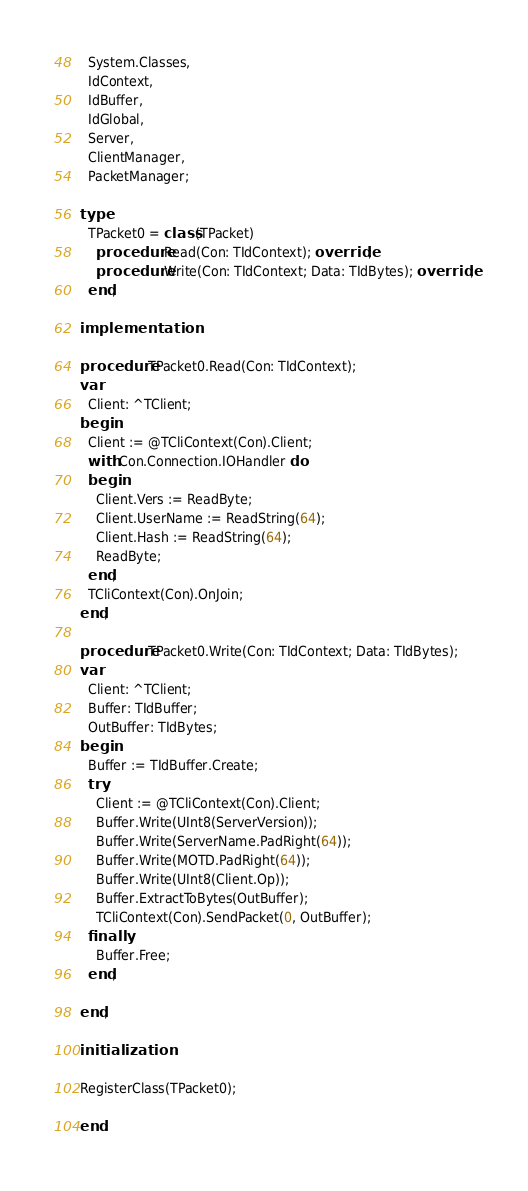Convert code to text. <code><loc_0><loc_0><loc_500><loc_500><_Pascal_>  System.Classes,
  IdContext,
  IdBuffer,
  IdGlobal,
  Server,
  ClientManager,
  PacketManager;

type
  TPacket0 = class(TPacket)
    procedure Read(Con: TIdContext); override;
    procedure Write(Con: TIdContext; Data: TIdBytes); override;
  end;

implementation

procedure TPacket0.Read(Con: TIdContext);
var
  Client: ^TClient;
begin
  Client := @TCliContext(Con).Client;
  with Con.Connection.IOHandler do
  begin
    Client.Vers := ReadByte;
    Client.UserName := ReadString(64);
    Client.Hash := ReadString(64);
    ReadByte;
  end;
  TCliContext(Con).OnJoin;
end;

procedure TPacket0.Write(Con: TIdContext; Data: TIdBytes);
var
  Client: ^TClient;
  Buffer: TIdBuffer;
  OutBuffer: TIdBytes;
begin
  Buffer := TIdBuffer.Create;
  try
    Client := @TCliContext(Con).Client;
    Buffer.Write(UInt8(ServerVersion));
    Buffer.Write(ServerName.PadRight(64));
    Buffer.Write(MOTD.PadRight(64));
    Buffer.Write(UInt8(Client.Op));
    Buffer.ExtractToBytes(OutBuffer);
    TCliContext(Con).SendPacket(0, OutBuffer);
  finally
    Buffer.Free;
  end;

end;

initialization

RegisterClass(TPacket0);

end.
</code> 